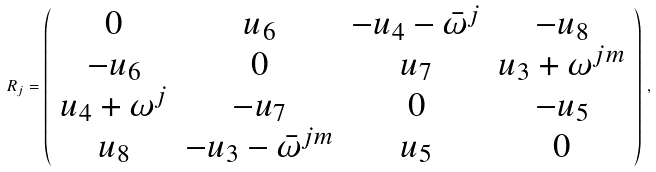<formula> <loc_0><loc_0><loc_500><loc_500>R _ { j } = \left ( \begin{array} { c c c c } 0 & u _ { 6 } & - u _ { 4 } - { \bar { \omega } } ^ { j } & - u _ { 8 } \\ - u _ { 6 } & 0 & u _ { 7 } & u _ { 3 } + \omega ^ { j m } \\ u _ { 4 } + \omega ^ { j } & - u _ { 7 } & 0 & - u _ { 5 } \\ u _ { 8 } & - u _ { 3 } - { \bar { \omega } } ^ { j m } & u _ { 5 } & 0 \end{array} \right ) \, ,</formula> 